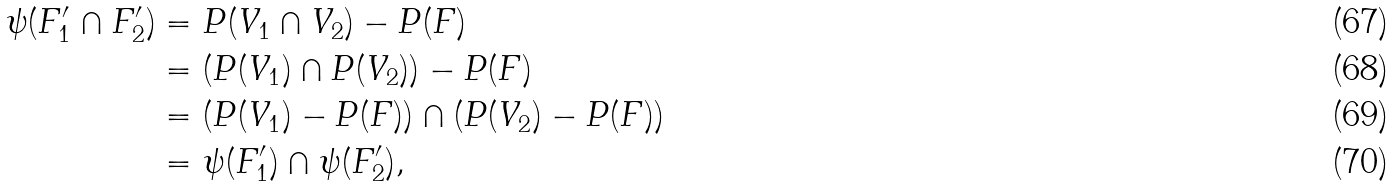Convert formula to latex. <formula><loc_0><loc_0><loc_500><loc_500>\psi ( F _ { 1 } ^ { \prime } \cap F _ { 2 } ^ { \prime } ) & = P ( V _ { 1 } \cap V _ { 2 } ) - P ( F ) \\ & = ( P ( V _ { 1 } ) \cap P ( V _ { 2 } ) ) - P ( F ) \\ & = ( P ( V _ { 1 } ) - P ( F ) ) \cap ( P ( V _ { 2 } ) - P ( F ) ) \\ & = \psi ( F _ { 1 } ^ { \prime } ) \cap \psi ( F _ { 2 } ^ { \prime } ) ,</formula> 